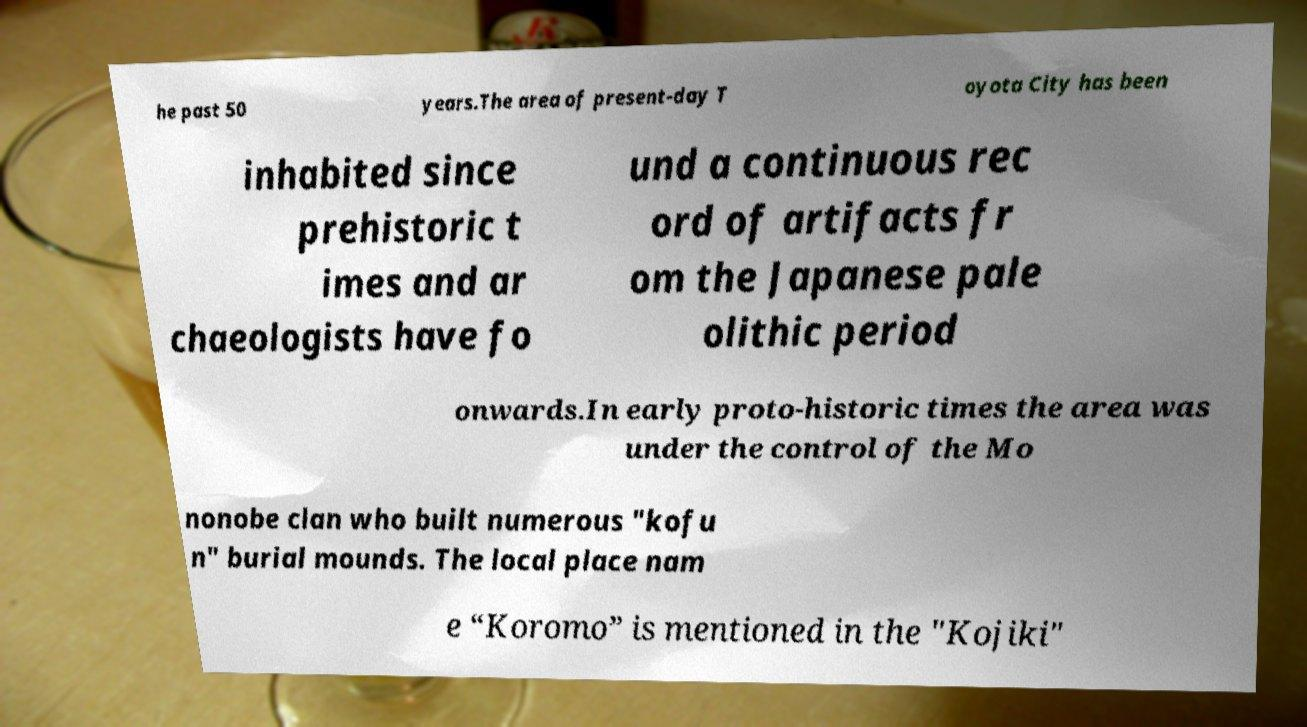Can you read and provide the text displayed in the image?This photo seems to have some interesting text. Can you extract and type it out for me? he past 50 years.The area of present-day T oyota City has been inhabited since prehistoric t imes and ar chaeologists have fo und a continuous rec ord of artifacts fr om the Japanese pale olithic period onwards.In early proto-historic times the area was under the control of the Mo nonobe clan who built numerous "kofu n" burial mounds. The local place nam e “Koromo” is mentioned in the "Kojiki" 